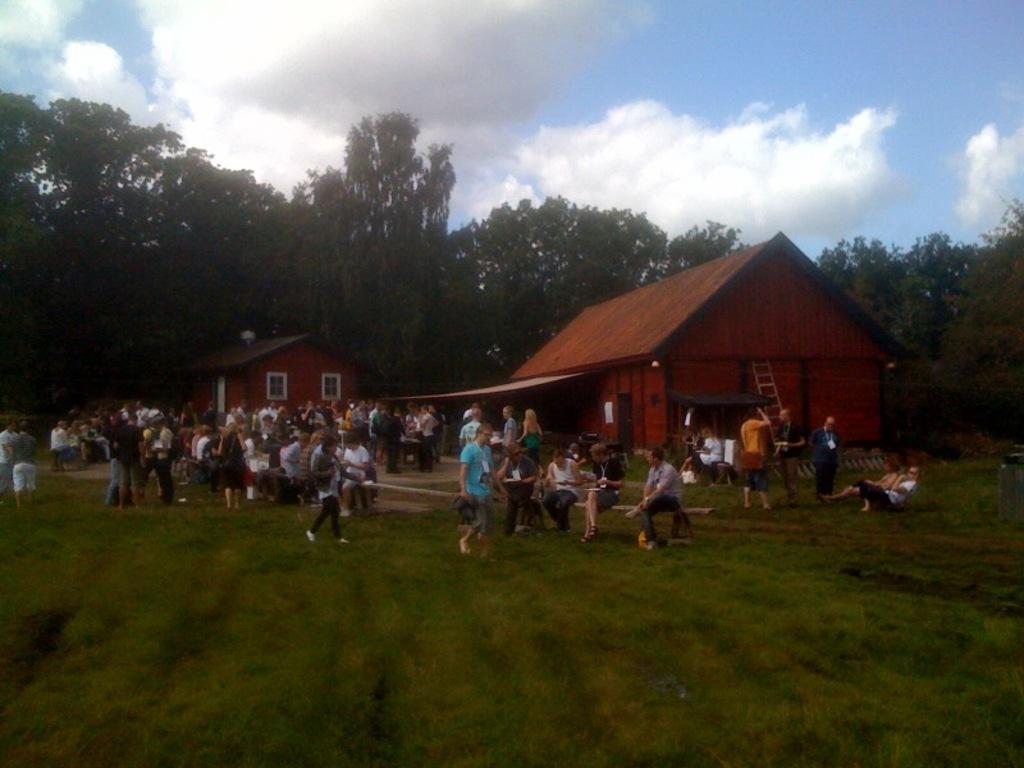How would you summarize this image in a sentence or two? In this image there are trees, houses, people, grass, ladder, cloudy sky and objects. Land is covered with grass. Among them few people are walking. 